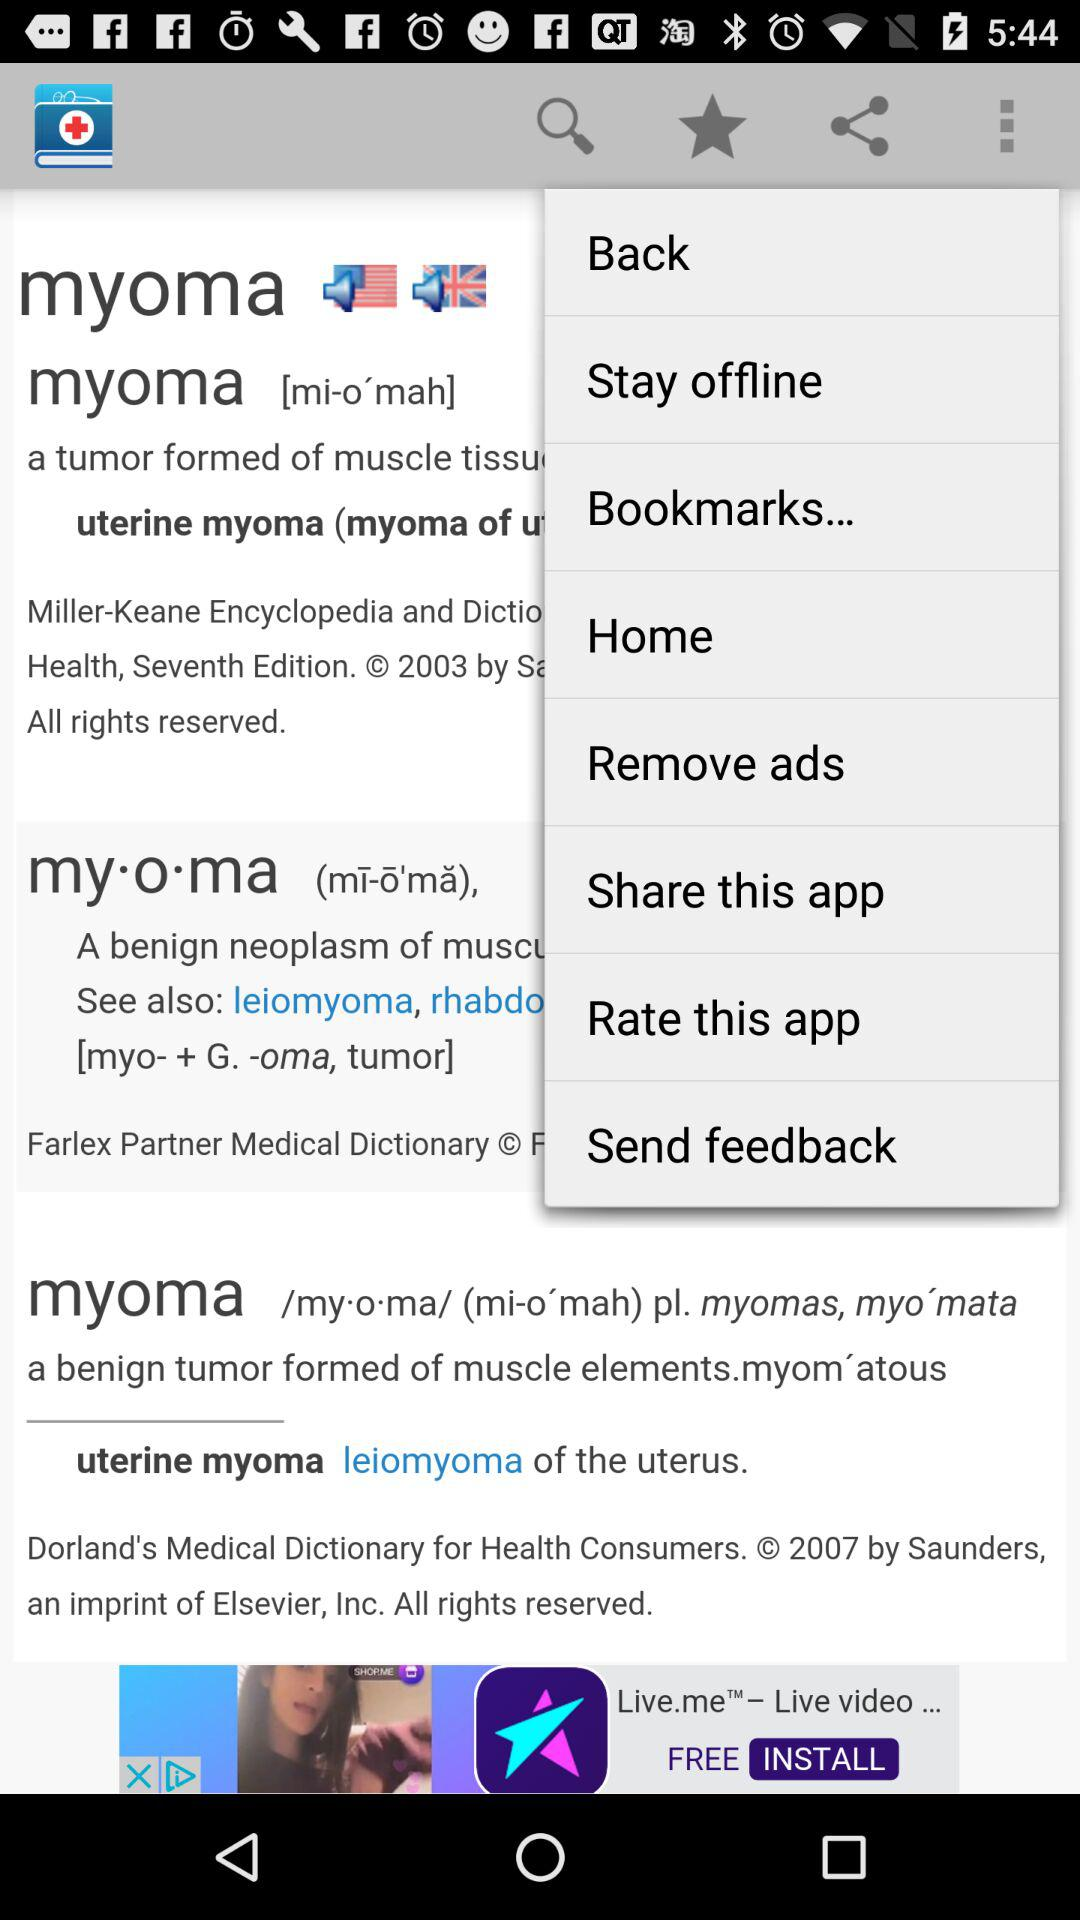What medical condition is described on the smartphone screen? The smartphone screen shows a definition of 'myoma', which is a type of tumor formed from muscle tissue, most commonly associated with the uterus, hence often referred to as uterine myoma or fibroids. 